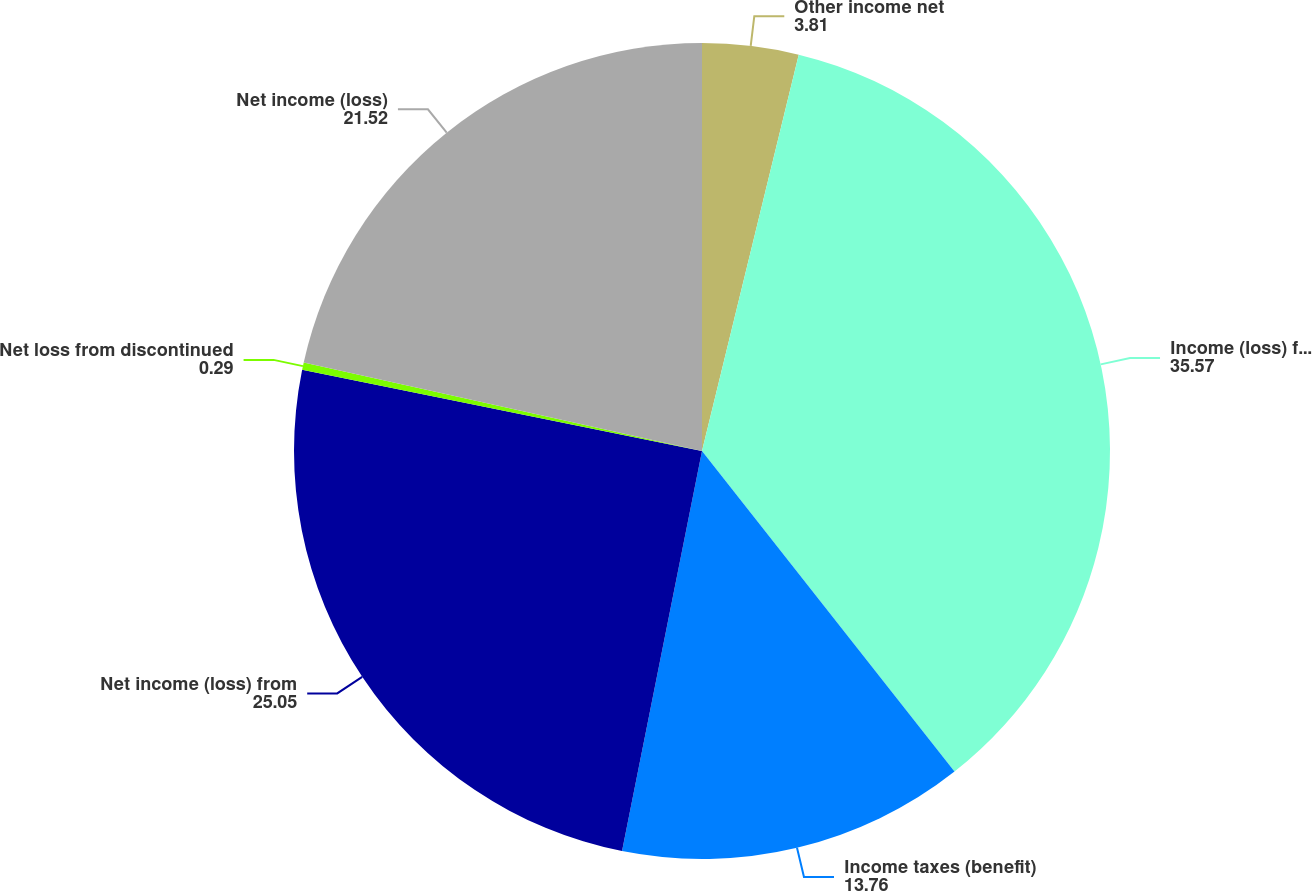<chart> <loc_0><loc_0><loc_500><loc_500><pie_chart><fcel>Other income net<fcel>Income (loss) from continuing<fcel>Income taxes (benefit)<fcel>Net income (loss) from<fcel>Net loss from discontinued<fcel>Net income (loss)<nl><fcel>3.81%<fcel>35.57%<fcel>13.76%<fcel>25.05%<fcel>0.29%<fcel>21.52%<nl></chart> 